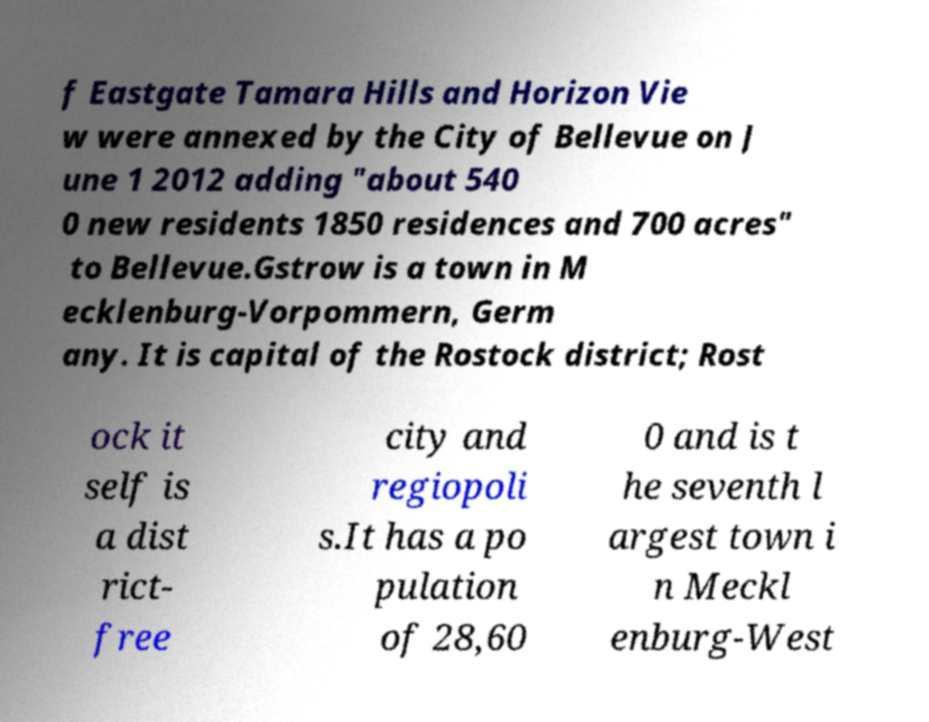For documentation purposes, I need the text within this image transcribed. Could you provide that? f Eastgate Tamara Hills and Horizon Vie w were annexed by the City of Bellevue on J une 1 2012 adding "about 540 0 new residents 1850 residences and 700 acres" to Bellevue.Gstrow is a town in M ecklenburg-Vorpommern, Germ any. It is capital of the Rostock district; Rost ock it self is a dist rict- free city and regiopoli s.It has a po pulation of 28,60 0 and is t he seventh l argest town i n Meckl enburg-West 